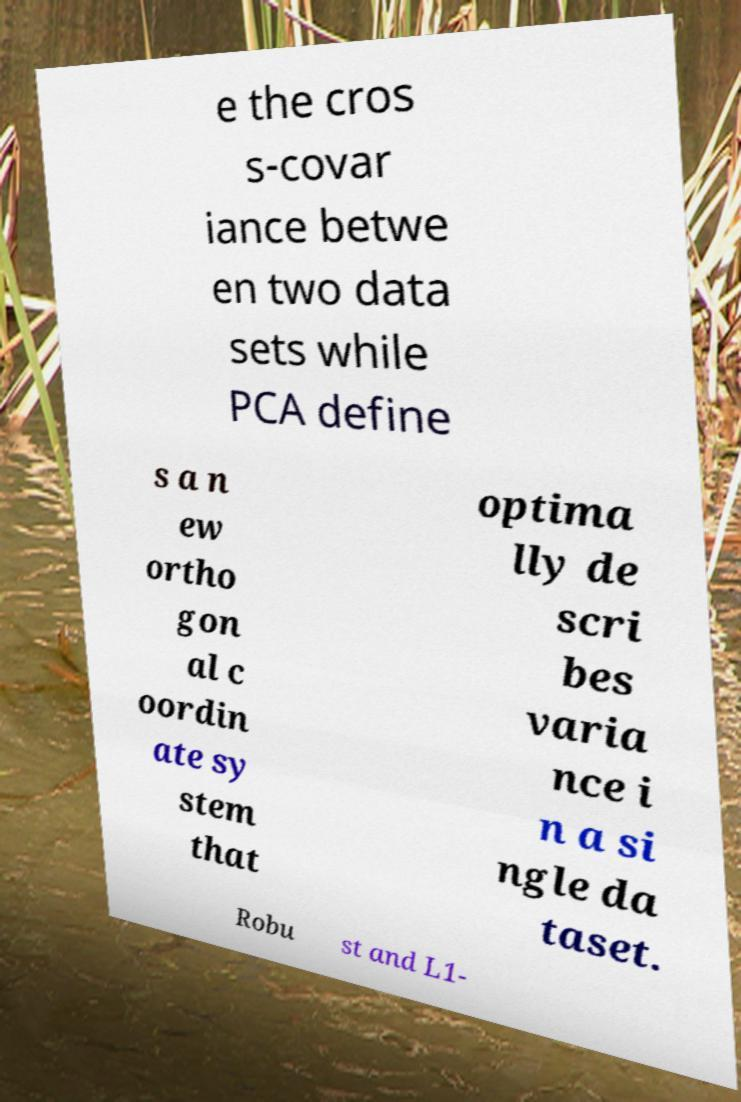There's text embedded in this image that I need extracted. Can you transcribe it verbatim? e the cros s-covar iance betwe en two data sets while PCA define s a n ew ortho gon al c oordin ate sy stem that optima lly de scri bes varia nce i n a si ngle da taset. Robu st and L1- 